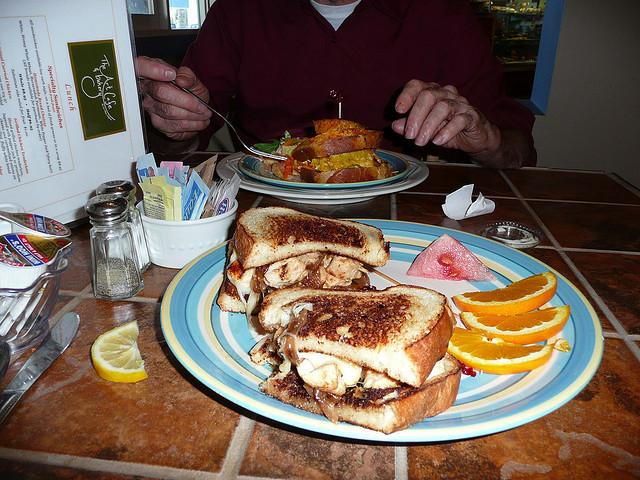How long would it take to eat this meal?
Answer briefly. Hour. Are they having lunch?
Quick response, please. Yes. How many orange slices are there?
Short answer required. 3. 